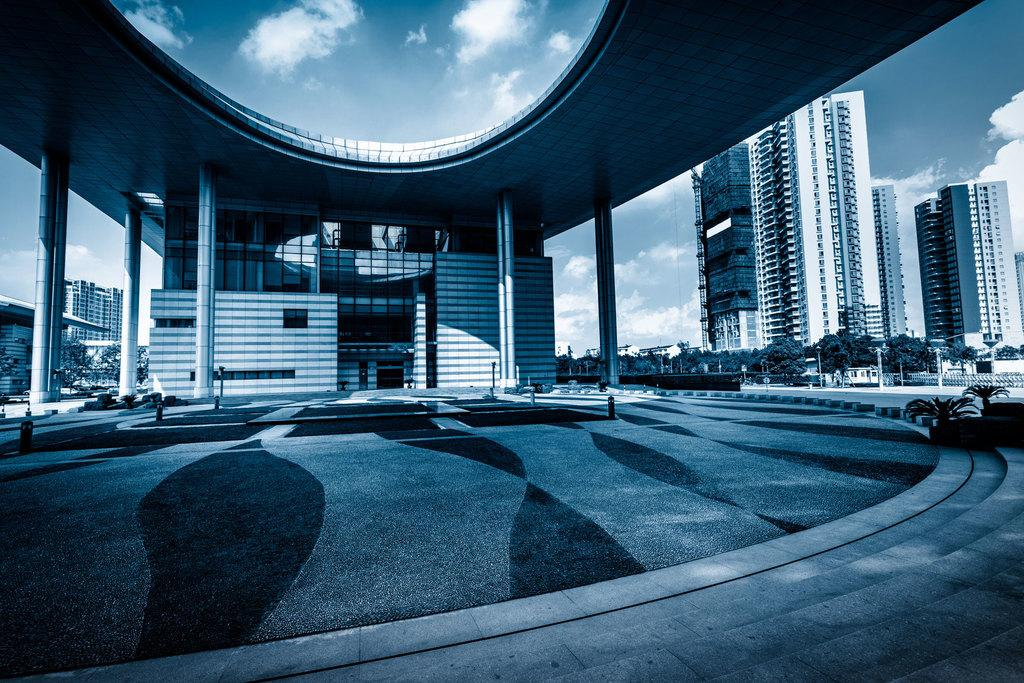What type of structures can be seen in the image? There are buildings in the image. What natural elements are present in the image? There are trees and plants in the image. What man-made objects can be seen in the image? There are poles and pillars in the image. What is the condition of the sky in the image? The sky is cloudy in the image. How many different types of objects are visible in the image? There are at least seven different types of objects visible in the image: buildings, trees, plants, poles, pillars, and objects. What plot of land is being discussed in the image? There is no specific plot of land being discussed in the image; it simply shows various objects and structures. What statement can be made about the reason for the cloudy sky in the image? There is no statement about the reason for the cloudy sky in the image, as the cause of the cloudy sky is not mentioned or implied. 